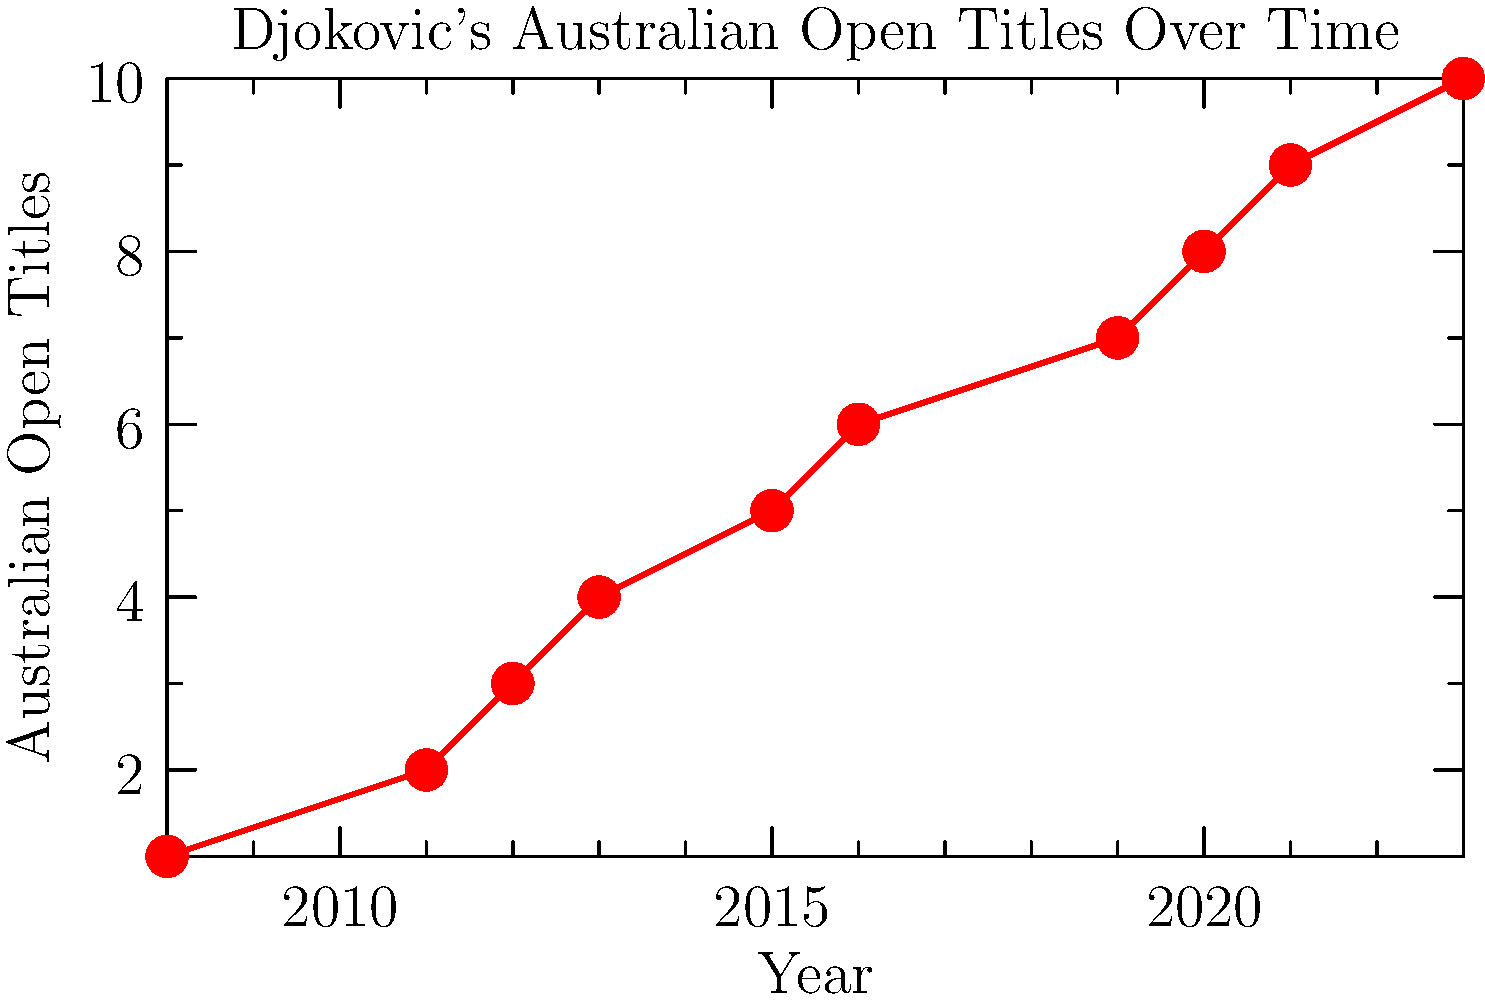Based on the line graph showing Novak Djokovic's Australian Open titles over time, calculate the average number of years between his consecutive title wins. What does this statistic suggest about his dominance in the tournament? To calculate the average number of years between Djokovic's consecutive title wins:

1. Identify the years of his title wins from the graph: 2008, 2011, 2012, 2013, 2015, 2016, 2019, 2020, 2021, 2023.

2. Calculate the time gaps between consecutive wins:
   2011 - 2008 = 3 years
   2012 - 2011 = 1 year
   2013 - 2012 = 1 year
   2015 - 2013 = 2 years
   2016 - 2015 = 1 year
   2019 - 2016 = 3 years
   2020 - 2019 = 1 year
   2021 - 2020 = 1 year
   2023 - 2021 = 2 years

3. Sum up these gaps: 3 + 1 + 1 + 2 + 1 + 3 + 1 + 1 + 2 = 15 years

4. Count the number of gaps: 9

5. Calculate the average: 15 years ÷ 9 = 1.67 years

The average of 1.67 years between consecutive wins suggests strong dominance in the tournament. This relatively short time between wins indicates consistent high performance and frequent success at the Australian Open over a 15-year period.
Answer: 1.67 years; indicating strong dominance 